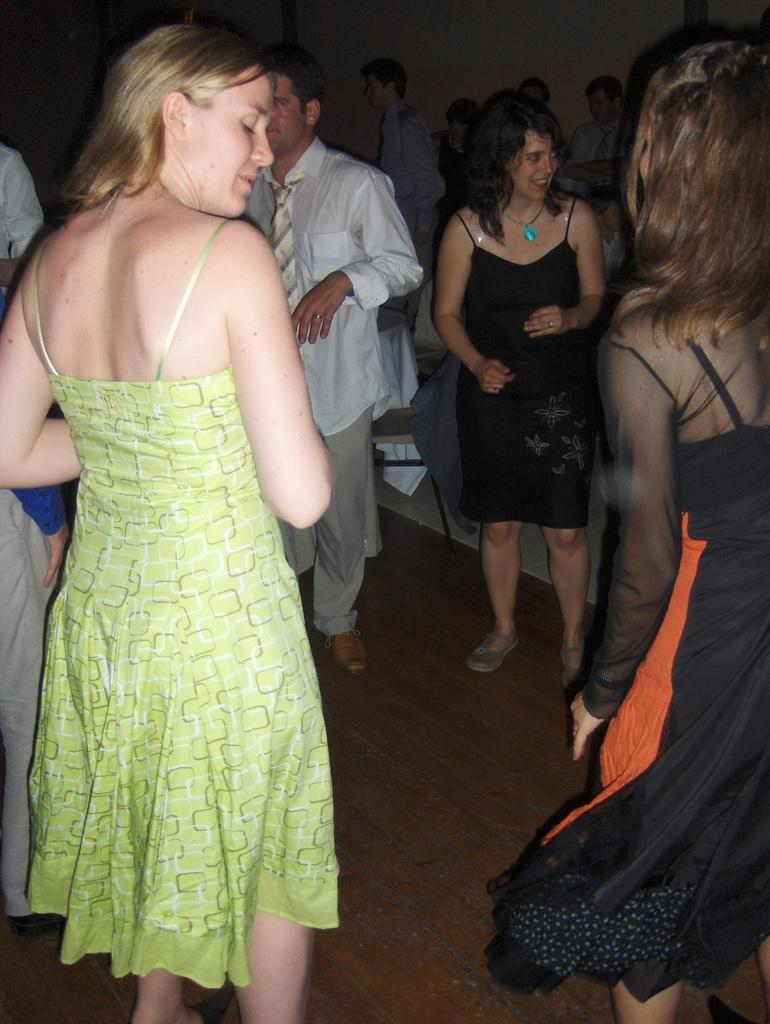What is the main subject of the image? The main subject of the image is a group of people. Where are the people located in the image? The people are standing on the floor. What can be seen in the background of the image? There is a chair and a wall in the background of the image. What type of game is being played by the people in the image? There is no game being played in the image; it only shows a group of people standing on the floor. Can you tell me the author of the prose that is being read by the people in the image? There is no prose or reading activity depicted in the image; it only shows a group of people standing on the floor. 